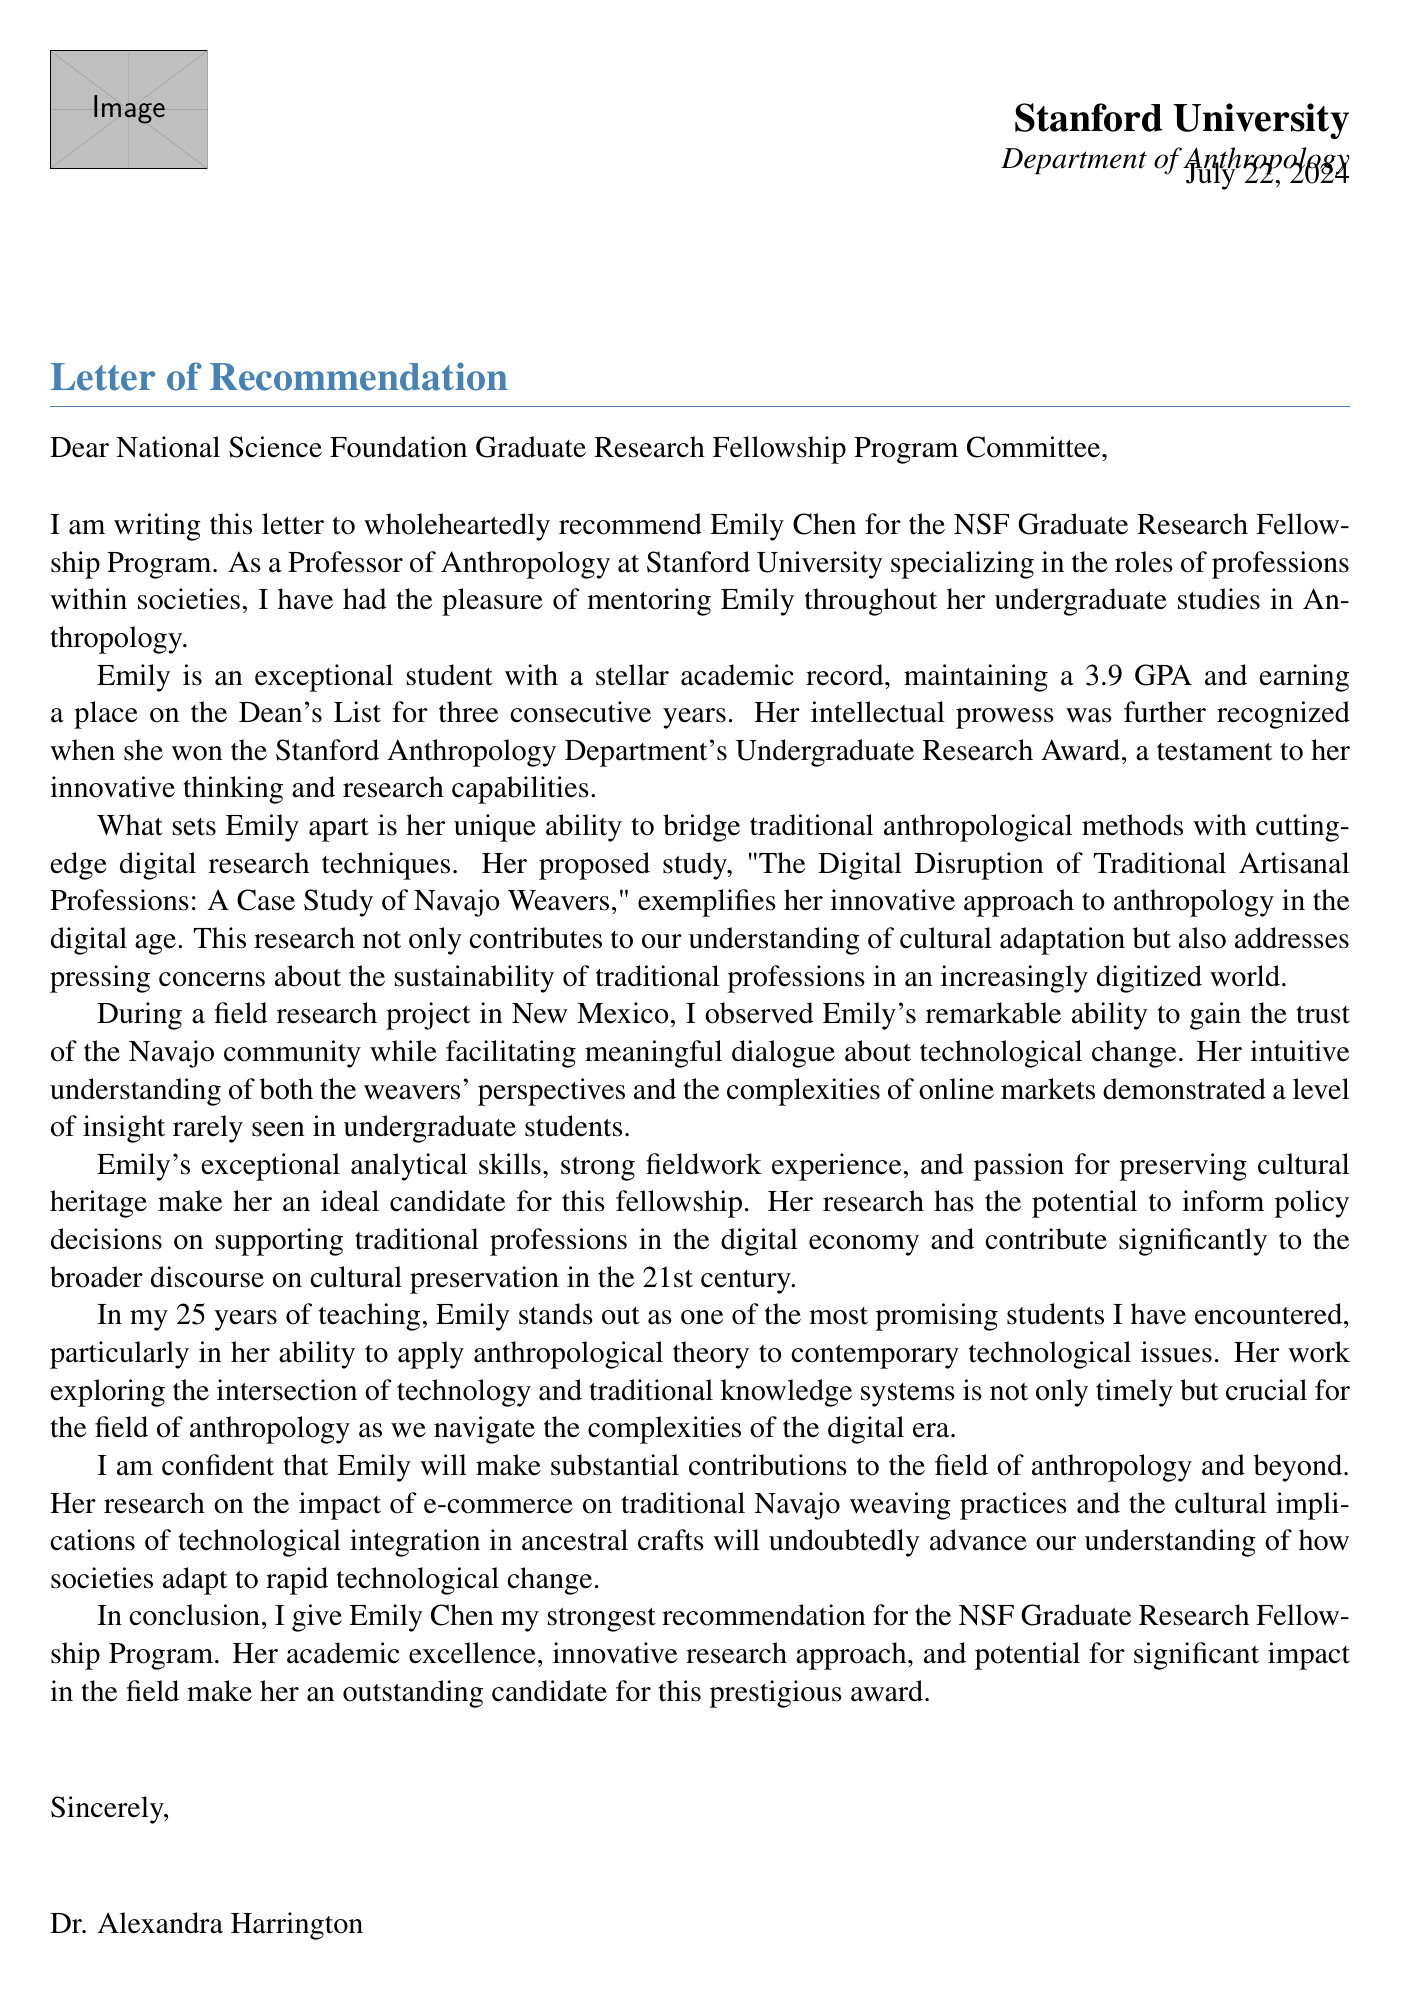What is the student's name? The letter explicitly states the student's name as Emily Chen.
Answer: Emily Chen What is Emily Chen's GPA? The document mentions that she maintains a 3.9 GPA.
Answer: 3.9 Who wrote the letter of recommendation? The letter identifies Dr. Alexandra Harrington as the author.
Answer: Dr. Alexandra Harrington What is the title of Emily's research proposal? The letter provides the title "The Digital Disruption of Traditional Artisanal Professions: A Case Study of Navajo Weavers."
Answer: The Digital Disruption of Traditional Artisanal Professions: A Case Study of Navajo Weavers What award did Emily win? The document notes that she won the Stanford Anthropology Department's Undergraduate Research Award.
Answer: Undergraduate Research Award How many years has Dr. Harrington been teaching? The letter states that she has been teaching for 25 years.
Answer: 25 years What is the focus of the National Science Foundation Graduate Research Fellowship Program? The document states that the focus is on interdisciplinary research on technology and society.
Answer: Interdisciplinary research on technology and society What is one of Emily's personal qualities mentioned in the letter? The letter highlights her exceptional analytical skills as a personal quality.
Answer: Exceptional analytical skills How does the proposed study relate to the field of Anthropology? The letter explains that it contributes to understanding cultural adaptation in the digital age.
Answer: Understanding of cultural adaptation in the digital age 